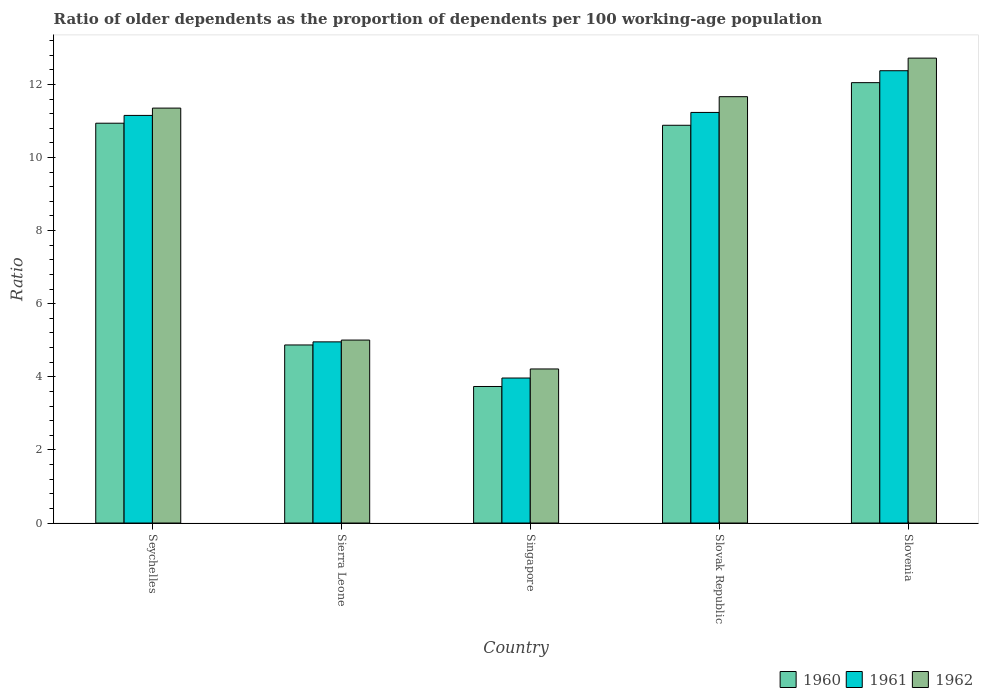How many different coloured bars are there?
Your answer should be compact. 3. How many groups of bars are there?
Give a very brief answer. 5. Are the number of bars on each tick of the X-axis equal?
Ensure brevity in your answer.  Yes. How many bars are there on the 4th tick from the right?
Offer a very short reply. 3. What is the label of the 1st group of bars from the left?
Keep it short and to the point. Seychelles. In how many cases, is the number of bars for a given country not equal to the number of legend labels?
Your answer should be compact. 0. What is the age dependency ratio(old) in 1961 in Singapore?
Your answer should be compact. 3.97. Across all countries, what is the maximum age dependency ratio(old) in 1960?
Your answer should be very brief. 12.05. Across all countries, what is the minimum age dependency ratio(old) in 1962?
Provide a short and direct response. 4.22. In which country was the age dependency ratio(old) in 1960 maximum?
Offer a very short reply. Slovenia. In which country was the age dependency ratio(old) in 1960 minimum?
Your response must be concise. Singapore. What is the total age dependency ratio(old) in 1962 in the graph?
Keep it short and to the point. 44.96. What is the difference between the age dependency ratio(old) in 1962 in Sierra Leone and that in Singapore?
Your response must be concise. 0.79. What is the difference between the age dependency ratio(old) in 1962 in Slovak Republic and the age dependency ratio(old) in 1960 in Singapore?
Your answer should be very brief. 7.93. What is the average age dependency ratio(old) in 1960 per country?
Provide a succinct answer. 8.5. What is the difference between the age dependency ratio(old) of/in 1962 and age dependency ratio(old) of/in 1961 in Sierra Leone?
Your answer should be compact. 0.05. In how many countries, is the age dependency ratio(old) in 1960 greater than 1.2000000000000002?
Make the answer very short. 5. What is the ratio of the age dependency ratio(old) in 1960 in Singapore to that in Slovenia?
Offer a terse response. 0.31. Is the age dependency ratio(old) in 1961 in Sierra Leone less than that in Slovak Republic?
Give a very brief answer. Yes. Is the difference between the age dependency ratio(old) in 1962 in Seychelles and Slovenia greater than the difference between the age dependency ratio(old) in 1961 in Seychelles and Slovenia?
Provide a succinct answer. No. What is the difference between the highest and the second highest age dependency ratio(old) in 1962?
Make the answer very short. -0.31. What is the difference between the highest and the lowest age dependency ratio(old) in 1960?
Your answer should be very brief. 8.31. Is the sum of the age dependency ratio(old) in 1960 in Seychelles and Slovenia greater than the maximum age dependency ratio(old) in 1962 across all countries?
Make the answer very short. Yes. What does the 3rd bar from the left in Sierra Leone represents?
Make the answer very short. 1962. What does the 3rd bar from the right in Slovenia represents?
Provide a short and direct response. 1960. Is it the case that in every country, the sum of the age dependency ratio(old) in 1961 and age dependency ratio(old) in 1962 is greater than the age dependency ratio(old) in 1960?
Ensure brevity in your answer.  Yes. How many countries are there in the graph?
Your answer should be compact. 5. Are the values on the major ticks of Y-axis written in scientific E-notation?
Provide a short and direct response. No. Does the graph contain grids?
Provide a short and direct response. No. What is the title of the graph?
Provide a short and direct response. Ratio of older dependents as the proportion of dependents per 100 working-age population. Does "1992" appear as one of the legend labels in the graph?
Your answer should be compact. No. What is the label or title of the X-axis?
Provide a short and direct response. Country. What is the label or title of the Y-axis?
Offer a terse response. Ratio. What is the Ratio in 1960 in Seychelles?
Make the answer very short. 10.94. What is the Ratio in 1961 in Seychelles?
Offer a very short reply. 11.15. What is the Ratio in 1962 in Seychelles?
Your response must be concise. 11.35. What is the Ratio of 1960 in Sierra Leone?
Offer a very short reply. 4.87. What is the Ratio in 1961 in Sierra Leone?
Provide a short and direct response. 4.96. What is the Ratio in 1962 in Sierra Leone?
Your answer should be compact. 5.01. What is the Ratio of 1960 in Singapore?
Your answer should be very brief. 3.74. What is the Ratio of 1961 in Singapore?
Give a very brief answer. 3.97. What is the Ratio of 1962 in Singapore?
Offer a very short reply. 4.22. What is the Ratio in 1960 in Slovak Republic?
Keep it short and to the point. 10.88. What is the Ratio of 1961 in Slovak Republic?
Provide a succinct answer. 11.23. What is the Ratio of 1962 in Slovak Republic?
Provide a short and direct response. 11.66. What is the Ratio of 1960 in Slovenia?
Offer a very short reply. 12.05. What is the Ratio in 1961 in Slovenia?
Provide a succinct answer. 12.37. What is the Ratio of 1962 in Slovenia?
Your answer should be very brief. 12.72. Across all countries, what is the maximum Ratio of 1960?
Your answer should be compact. 12.05. Across all countries, what is the maximum Ratio in 1961?
Provide a succinct answer. 12.37. Across all countries, what is the maximum Ratio in 1962?
Your answer should be very brief. 12.72. Across all countries, what is the minimum Ratio in 1960?
Provide a short and direct response. 3.74. Across all countries, what is the minimum Ratio of 1961?
Offer a very short reply. 3.97. Across all countries, what is the minimum Ratio in 1962?
Ensure brevity in your answer.  4.22. What is the total Ratio of 1960 in the graph?
Your response must be concise. 42.48. What is the total Ratio in 1961 in the graph?
Provide a short and direct response. 43.68. What is the total Ratio in 1962 in the graph?
Provide a short and direct response. 44.96. What is the difference between the Ratio of 1960 in Seychelles and that in Sierra Leone?
Give a very brief answer. 6.07. What is the difference between the Ratio in 1961 in Seychelles and that in Sierra Leone?
Give a very brief answer. 6.2. What is the difference between the Ratio in 1962 in Seychelles and that in Sierra Leone?
Offer a very short reply. 6.35. What is the difference between the Ratio of 1960 in Seychelles and that in Singapore?
Your answer should be compact. 7.2. What is the difference between the Ratio in 1961 in Seychelles and that in Singapore?
Offer a very short reply. 7.18. What is the difference between the Ratio of 1962 in Seychelles and that in Singapore?
Your answer should be very brief. 7.14. What is the difference between the Ratio of 1960 in Seychelles and that in Slovak Republic?
Your answer should be compact. 0.06. What is the difference between the Ratio of 1961 in Seychelles and that in Slovak Republic?
Offer a terse response. -0.08. What is the difference between the Ratio in 1962 in Seychelles and that in Slovak Republic?
Provide a short and direct response. -0.31. What is the difference between the Ratio of 1960 in Seychelles and that in Slovenia?
Offer a terse response. -1.11. What is the difference between the Ratio in 1961 in Seychelles and that in Slovenia?
Ensure brevity in your answer.  -1.22. What is the difference between the Ratio of 1962 in Seychelles and that in Slovenia?
Offer a very short reply. -1.37. What is the difference between the Ratio of 1960 in Sierra Leone and that in Singapore?
Your answer should be very brief. 1.14. What is the difference between the Ratio of 1961 in Sierra Leone and that in Singapore?
Your answer should be compact. 0.99. What is the difference between the Ratio in 1962 in Sierra Leone and that in Singapore?
Keep it short and to the point. 0.79. What is the difference between the Ratio of 1960 in Sierra Leone and that in Slovak Republic?
Your response must be concise. -6.01. What is the difference between the Ratio of 1961 in Sierra Leone and that in Slovak Republic?
Make the answer very short. -6.28. What is the difference between the Ratio in 1962 in Sierra Leone and that in Slovak Republic?
Ensure brevity in your answer.  -6.66. What is the difference between the Ratio of 1960 in Sierra Leone and that in Slovenia?
Your answer should be very brief. -7.18. What is the difference between the Ratio of 1961 in Sierra Leone and that in Slovenia?
Your answer should be very brief. -7.42. What is the difference between the Ratio of 1962 in Sierra Leone and that in Slovenia?
Provide a short and direct response. -7.71. What is the difference between the Ratio of 1960 in Singapore and that in Slovak Republic?
Keep it short and to the point. -7.15. What is the difference between the Ratio in 1961 in Singapore and that in Slovak Republic?
Your response must be concise. -7.27. What is the difference between the Ratio in 1962 in Singapore and that in Slovak Republic?
Provide a short and direct response. -7.45. What is the difference between the Ratio of 1960 in Singapore and that in Slovenia?
Ensure brevity in your answer.  -8.31. What is the difference between the Ratio in 1961 in Singapore and that in Slovenia?
Your answer should be very brief. -8.41. What is the difference between the Ratio of 1962 in Singapore and that in Slovenia?
Provide a short and direct response. -8.5. What is the difference between the Ratio of 1960 in Slovak Republic and that in Slovenia?
Provide a short and direct response. -1.17. What is the difference between the Ratio in 1961 in Slovak Republic and that in Slovenia?
Offer a terse response. -1.14. What is the difference between the Ratio in 1962 in Slovak Republic and that in Slovenia?
Your answer should be very brief. -1.05. What is the difference between the Ratio of 1960 in Seychelles and the Ratio of 1961 in Sierra Leone?
Your response must be concise. 5.98. What is the difference between the Ratio in 1960 in Seychelles and the Ratio in 1962 in Sierra Leone?
Your answer should be very brief. 5.93. What is the difference between the Ratio of 1961 in Seychelles and the Ratio of 1962 in Sierra Leone?
Give a very brief answer. 6.15. What is the difference between the Ratio of 1960 in Seychelles and the Ratio of 1961 in Singapore?
Give a very brief answer. 6.97. What is the difference between the Ratio of 1960 in Seychelles and the Ratio of 1962 in Singapore?
Your answer should be compact. 6.72. What is the difference between the Ratio in 1961 in Seychelles and the Ratio in 1962 in Singapore?
Your answer should be very brief. 6.94. What is the difference between the Ratio of 1960 in Seychelles and the Ratio of 1961 in Slovak Republic?
Give a very brief answer. -0.29. What is the difference between the Ratio of 1960 in Seychelles and the Ratio of 1962 in Slovak Republic?
Offer a terse response. -0.73. What is the difference between the Ratio of 1961 in Seychelles and the Ratio of 1962 in Slovak Republic?
Provide a short and direct response. -0.51. What is the difference between the Ratio in 1960 in Seychelles and the Ratio in 1961 in Slovenia?
Your response must be concise. -1.44. What is the difference between the Ratio of 1960 in Seychelles and the Ratio of 1962 in Slovenia?
Keep it short and to the point. -1.78. What is the difference between the Ratio in 1961 in Seychelles and the Ratio in 1962 in Slovenia?
Keep it short and to the point. -1.57. What is the difference between the Ratio in 1960 in Sierra Leone and the Ratio in 1961 in Singapore?
Offer a terse response. 0.9. What is the difference between the Ratio in 1960 in Sierra Leone and the Ratio in 1962 in Singapore?
Offer a terse response. 0.66. What is the difference between the Ratio in 1961 in Sierra Leone and the Ratio in 1962 in Singapore?
Ensure brevity in your answer.  0.74. What is the difference between the Ratio of 1960 in Sierra Leone and the Ratio of 1961 in Slovak Republic?
Make the answer very short. -6.36. What is the difference between the Ratio in 1960 in Sierra Leone and the Ratio in 1962 in Slovak Republic?
Offer a very short reply. -6.79. What is the difference between the Ratio of 1961 in Sierra Leone and the Ratio of 1962 in Slovak Republic?
Give a very brief answer. -6.71. What is the difference between the Ratio of 1960 in Sierra Leone and the Ratio of 1961 in Slovenia?
Your response must be concise. -7.5. What is the difference between the Ratio in 1960 in Sierra Leone and the Ratio in 1962 in Slovenia?
Provide a short and direct response. -7.85. What is the difference between the Ratio in 1961 in Sierra Leone and the Ratio in 1962 in Slovenia?
Ensure brevity in your answer.  -7.76. What is the difference between the Ratio in 1960 in Singapore and the Ratio in 1961 in Slovak Republic?
Your answer should be compact. -7.5. What is the difference between the Ratio in 1960 in Singapore and the Ratio in 1962 in Slovak Republic?
Ensure brevity in your answer.  -7.93. What is the difference between the Ratio of 1961 in Singapore and the Ratio of 1962 in Slovak Republic?
Make the answer very short. -7.7. What is the difference between the Ratio in 1960 in Singapore and the Ratio in 1961 in Slovenia?
Keep it short and to the point. -8.64. What is the difference between the Ratio of 1960 in Singapore and the Ratio of 1962 in Slovenia?
Offer a terse response. -8.98. What is the difference between the Ratio of 1961 in Singapore and the Ratio of 1962 in Slovenia?
Ensure brevity in your answer.  -8.75. What is the difference between the Ratio in 1960 in Slovak Republic and the Ratio in 1961 in Slovenia?
Ensure brevity in your answer.  -1.49. What is the difference between the Ratio in 1960 in Slovak Republic and the Ratio in 1962 in Slovenia?
Keep it short and to the point. -1.84. What is the difference between the Ratio in 1961 in Slovak Republic and the Ratio in 1962 in Slovenia?
Offer a very short reply. -1.49. What is the average Ratio in 1960 per country?
Make the answer very short. 8.5. What is the average Ratio of 1961 per country?
Ensure brevity in your answer.  8.74. What is the average Ratio of 1962 per country?
Ensure brevity in your answer.  8.99. What is the difference between the Ratio in 1960 and Ratio in 1961 in Seychelles?
Your response must be concise. -0.21. What is the difference between the Ratio of 1960 and Ratio of 1962 in Seychelles?
Keep it short and to the point. -0.41. What is the difference between the Ratio of 1961 and Ratio of 1962 in Seychelles?
Your response must be concise. -0.2. What is the difference between the Ratio of 1960 and Ratio of 1961 in Sierra Leone?
Ensure brevity in your answer.  -0.08. What is the difference between the Ratio in 1960 and Ratio in 1962 in Sierra Leone?
Keep it short and to the point. -0.13. What is the difference between the Ratio in 1961 and Ratio in 1962 in Sierra Leone?
Keep it short and to the point. -0.05. What is the difference between the Ratio in 1960 and Ratio in 1961 in Singapore?
Give a very brief answer. -0.23. What is the difference between the Ratio in 1960 and Ratio in 1962 in Singapore?
Your answer should be very brief. -0.48. What is the difference between the Ratio of 1961 and Ratio of 1962 in Singapore?
Provide a short and direct response. -0.25. What is the difference between the Ratio of 1960 and Ratio of 1961 in Slovak Republic?
Offer a terse response. -0.35. What is the difference between the Ratio in 1960 and Ratio in 1962 in Slovak Republic?
Offer a terse response. -0.78. What is the difference between the Ratio in 1961 and Ratio in 1962 in Slovak Republic?
Your response must be concise. -0.43. What is the difference between the Ratio of 1960 and Ratio of 1961 in Slovenia?
Make the answer very short. -0.33. What is the difference between the Ratio of 1960 and Ratio of 1962 in Slovenia?
Keep it short and to the point. -0.67. What is the difference between the Ratio in 1961 and Ratio in 1962 in Slovenia?
Keep it short and to the point. -0.34. What is the ratio of the Ratio of 1960 in Seychelles to that in Sierra Leone?
Provide a succinct answer. 2.25. What is the ratio of the Ratio in 1961 in Seychelles to that in Sierra Leone?
Provide a succinct answer. 2.25. What is the ratio of the Ratio of 1962 in Seychelles to that in Sierra Leone?
Provide a succinct answer. 2.27. What is the ratio of the Ratio in 1960 in Seychelles to that in Singapore?
Offer a terse response. 2.93. What is the ratio of the Ratio in 1961 in Seychelles to that in Singapore?
Ensure brevity in your answer.  2.81. What is the ratio of the Ratio in 1962 in Seychelles to that in Singapore?
Offer a terse response. 2.69. What is the ratio of the Ratio of 1962 in Seychelles to that in Slovak Republic?
Provide a short and direct response. 0.97. What is the ratio of the Ratio in 1960 in Seychelles to that in Slovenia?
Offer a terse response. 0.91. What is the ratio of the Ratio in 1961 in Seychelles to that in Slovenia?
Provide a succinct answer. 0.9. What is the ratio of the Ratio in 1962 in Seychelles to that in Slovenia?
Your answer should be compact. 0.89. What is the ratio of the Ratio of 1960 in Sierra Leone to that in Singapore?
Make the answer very short. 1.3. What is the ratio of the Ratio of 1961 in Sierra Leone to that in Singapore?
Provide a succinct answer. 1.25. What is the ratio of the Ratio in 1962 in Sierra Leone to that in Singapore?
Provide a succinct answer. 1.19. What is the ratio of the Ratio in 1960 in Sierra Leone to that in Slovak Republic?
Offer a very short reply. 0.45. What is the ratio of the Ratio of 1961 in Sierra Leone to that in Slovak Republic?
Offer a terse response. 0.44. What is the ratio of the Ratio of 1962 in Sierra Leone to that in Slovak Republic?
Keep it short and to the point. 0.43. What is the ratio of the Ratio of 1960 in Sierra Leone to that in Slovenia?
Your answer should be very brief. 0.4. What is the ratio of the Ratio of 1961 in Sierra Leone to that in Slovenia?
Your answer should be compact. 0.4. What is the ratio of the Ratio of 1962 in Sierra Leone to that in Slovenia?
Make the answer very short. 0.39. What is the ratio of the Ratio in 1960 in Singapore to that in Slovak Republic?
Ensure brevity in your answer.  0.34. What is the ratio of the Ratio in 1961 in Singapore to that in Slovak Republic?
Offer a terse response. 0.35. What is the ratio of the Ratio of 1962 in Singapore to that in Slovak Republic?
Provide a succinct answer. 0.36. What is the ratio of the Ratio in 1960 in Singapore to that in Slovenia?
Make the answer very short. 0.31. What is the ratio of the Ratio of 1961 in Singapore to that in Slovenia?
Give a very brief answer. 0.32. What is the ratio of the Ratio of 1962 in Singapore to that in Slovenia?
Make the answer very short. 0.33. What is the ratio of the Ratio of 1960 in Slovak Republic to that in Slovenia?
Your response must be concise. 0.9. What is the ratio of the Ratio in 1961 in Slovak Republic to that in Slovenia?
Your answer should be very brief. 0.91. What is the ratio of the Ratio of 1962 in Slovak Republic to that in Slovenia?
Your answer should be compact. 0.92. What is the difference between the highest and the second highest Ratio in 1960?
Provide a succinct answer. 1.11. What is the difference between the highest and the second highest Ratio of 1961?
Your answer should be compact. 1.14. What is the difference between the highest and the second highest Ratio in 1962?
Your answer should be compact. 1.05. What is the difference between the highest and the lowest Ratio of 1960?
Give a very brief answer. 8.31. What is the difference between the highest and the lowest Ratio in 1961?
Give a very brief answer. 8.41. What is the difference between the highest and the lowest Ratio in 1962?
Your answer should be compact. 8.5. 